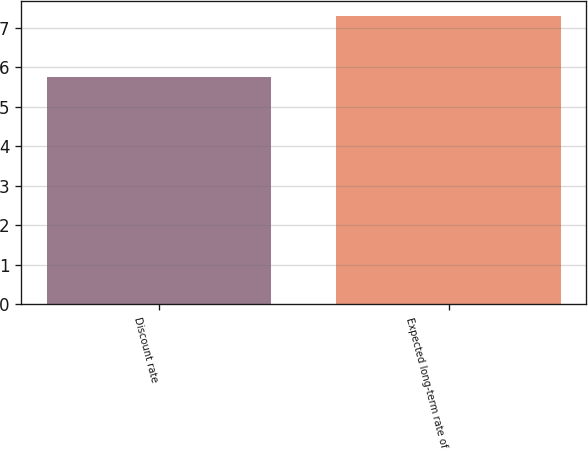Convert chart to OTSL. <chart><loc_0><loc_0><loc_500><loc_500><bar_chart><fcel>Discount rate<fcel>Expected long-term rate of<nl><fcel>5.75<fcel>7.3<nl></chart> 